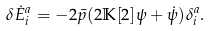Convert formula to latex. <formula><loc_0><loc_0><loc_500><loc_500>\delta \dot { E } ^ { a } _ { i } = - 2 \bar { p } ( 2 \mathbb { K } [ 2 ] \psi + \dot { \psi } ) \delta ^ { a } _ { i } .</formula> 